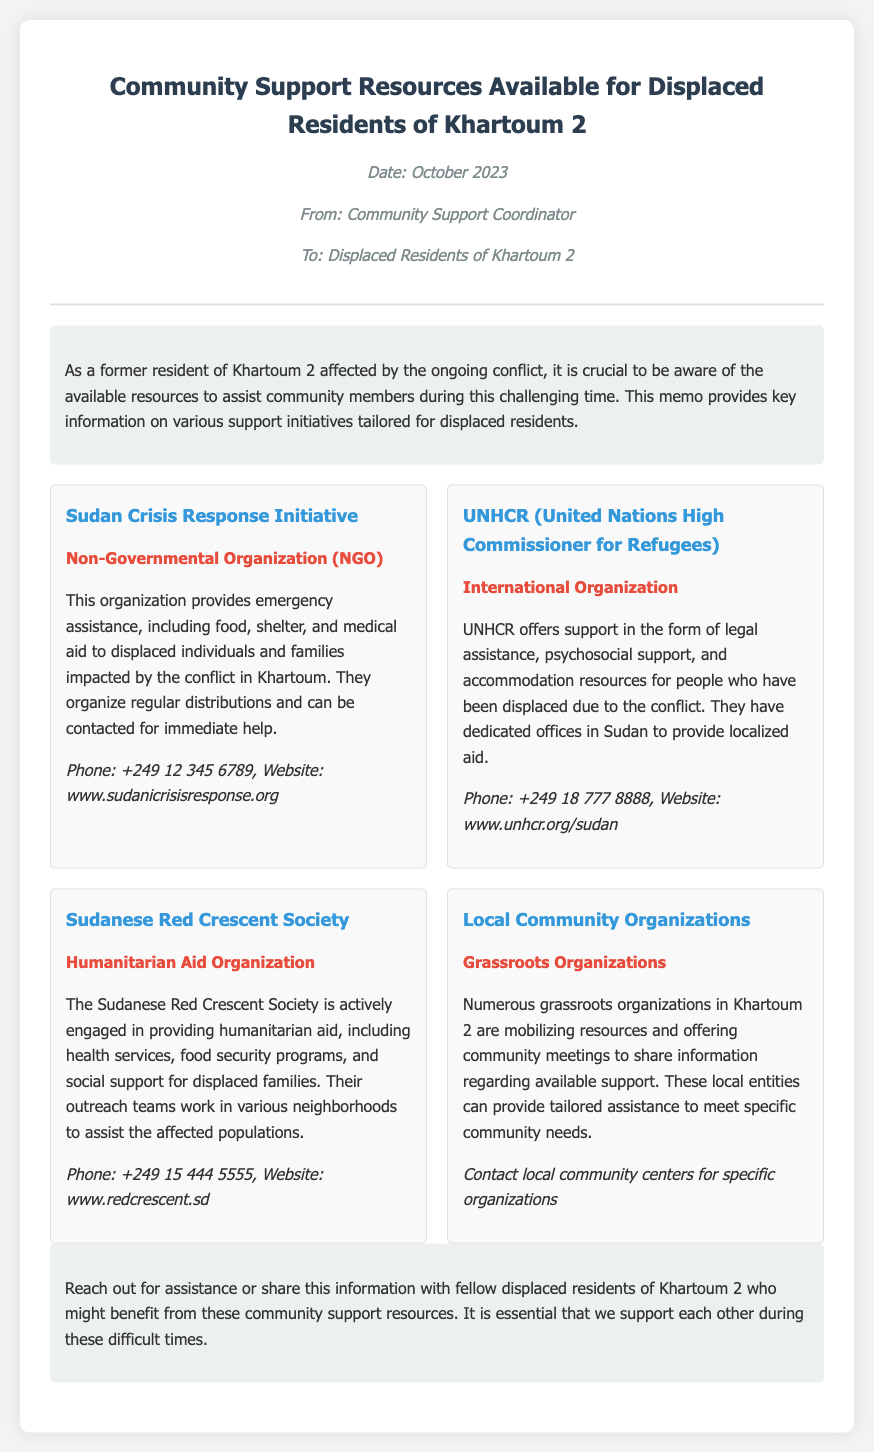What is the title of the memo? The title of the memo is provided in the header section of the document.
Answer: Community Support Resources Available for Displaced Residents of Khartoum 2 Who is the memo addressed to? The recipient of the memo is indicated in the "To" section of the header.
Answer: Displaced Residents of Khartoum 2 What is the contact phone number for the Sudan Crisis Response Initiative? The contact information for this organization is listed under their respective section.
Answer: +249 12 345 6789 What type of organization is UNHCR? The type of the organization is indicated in the document under their name.
Answer: International Organization What assistance does the Sudanese Red Crescent Society provide? The specific assistance offered is mentioned in their section of the memo.
Answer: Humanitarian aid How many support organizations are listed in the document? The number of organizations is counted based on the resources provided in the memo.
Answer: Four 